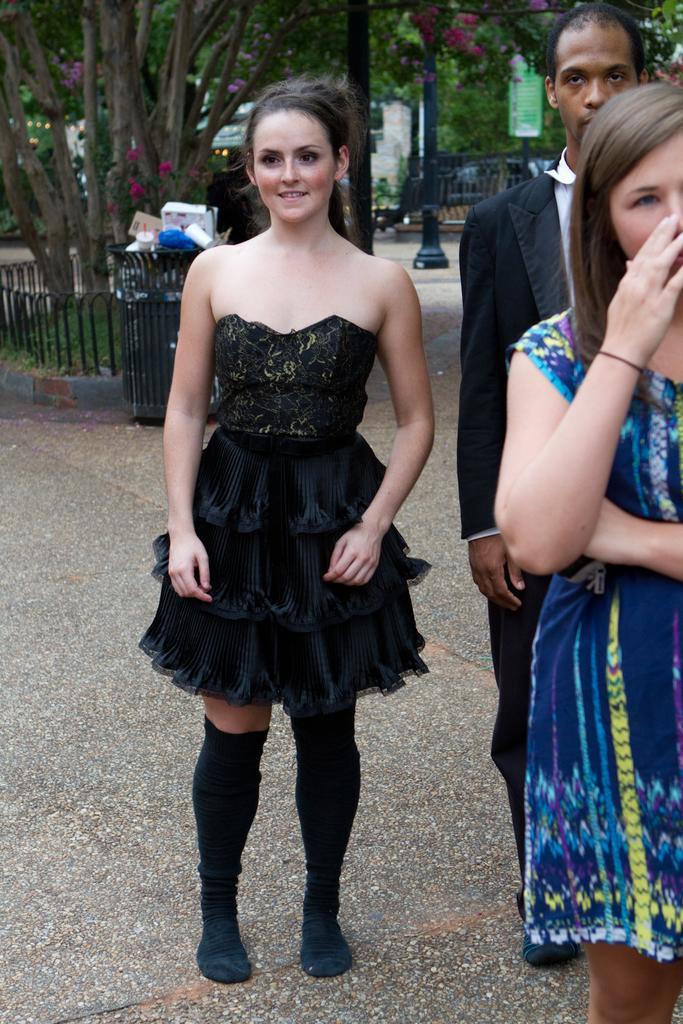Could you give a brief overview of what you see in this image? In the center of the image we can see a girl standing. She is wearing a black dress, next to her there is a man and a girl. In the background there are trees and a fence. We can see a bin. There is a pole. We can see flowers. 